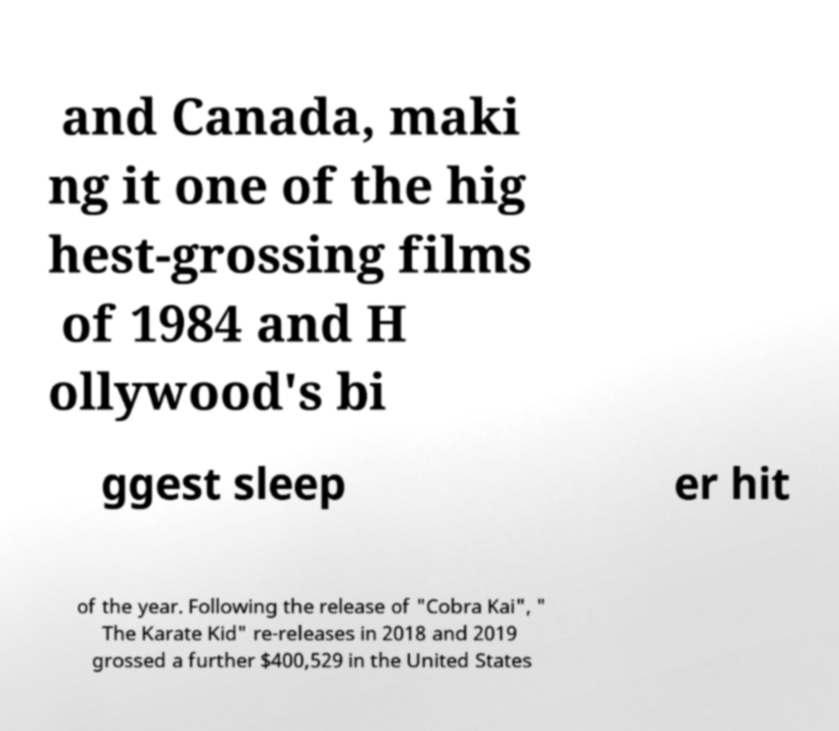Could you extract and type out the text from this image? and Canada, maki ng it one of the hig hest-grossing films of 1984 and H ollywood's bi ggest sleep er hit of the year. Following the release of "Cobra Kai", " The Karate Kid" re-releases in 2018 and 2019 grossed a further $400,529 in the United States 